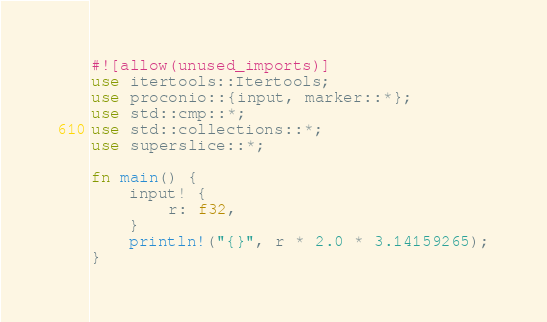<code> <loc_0><loc_0><loc_500><loc_500><_Rust_>#![allow(unused_imports)]
use itertools::Itertools;
use proconio::{input, marker::*};
use std::cmp::*;
use std::collections::*;
use superslice::*;

fn main() {
    input! {
        r: f32,
    }
    println!("{}", r * 2.0 * 3.14159265);
}
</code> 